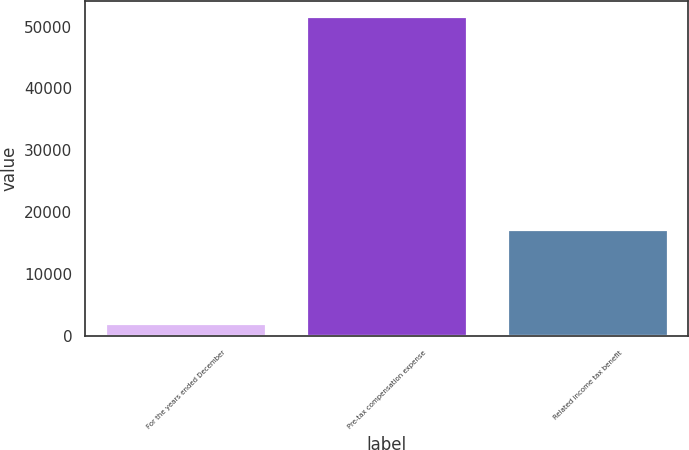Convert chart. <chart><loc_0><loc_0><loc_500><loc_500><bar_chart><fcel>For the years ended December<fcel>Pre-tax compensation expense<fcel>Related income tax benefit<nl><fcel>2015<fcel>51533<fcel>17109<nl></chart> 